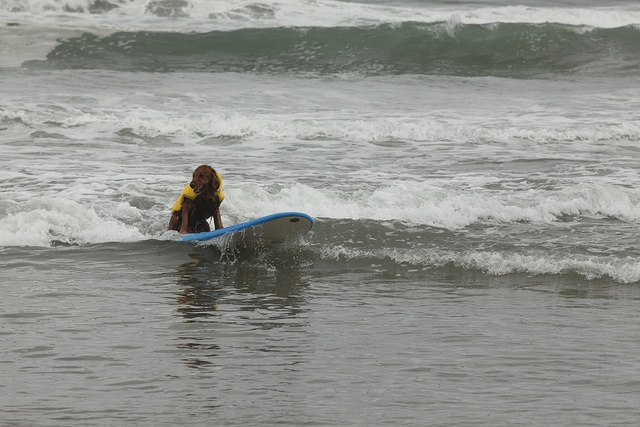Describe the objects in this image and their specific colors. I can see dog in darkgray, black, maroon, and olive tones and surfboard in darkgray, gray, and black tones in this image. 